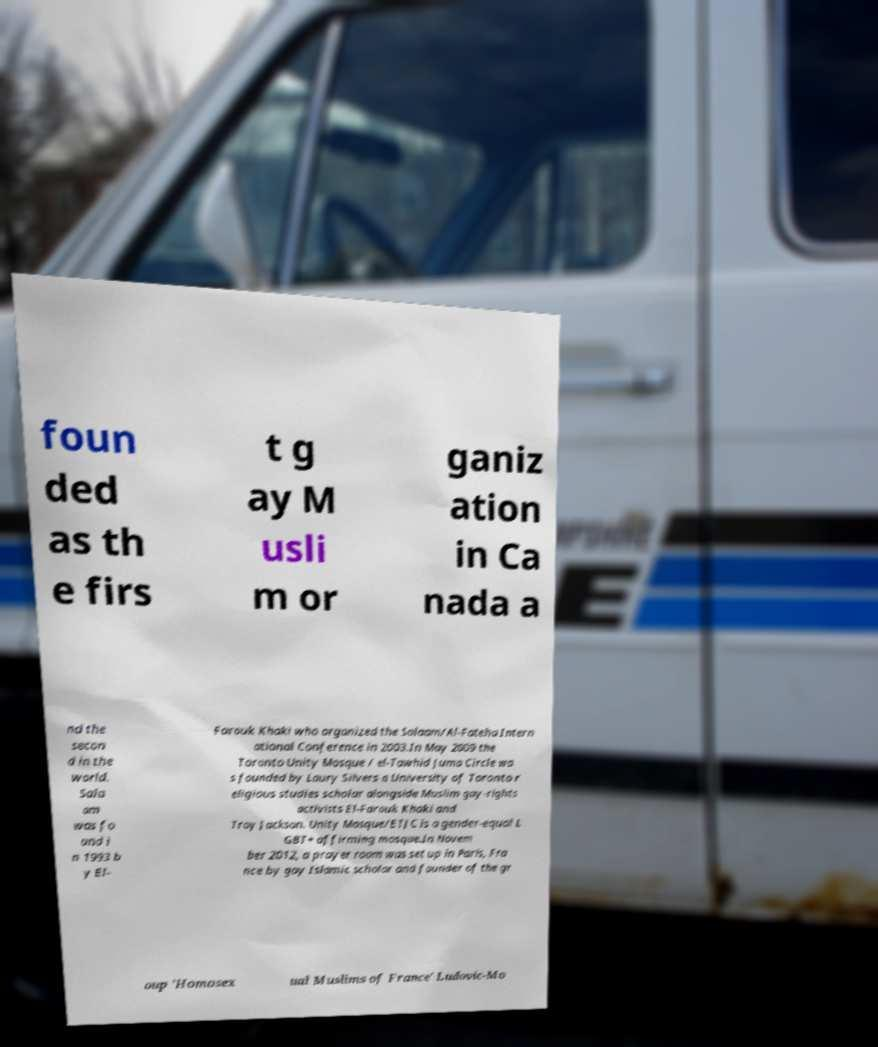Could you extract and type out the text from this image? foun ded as th e firs t g ay M usli m or ganiz ation in Ca nada a nd the secon d in the world. Sala am was fo und i n 1993 b y El- Farouk Khaki who organized the Salaam/Al-Fateha Intern ational Conference in 2003.In May 2009 the Toronto Unity Mosque / el-Tawhid Juma Circle wa s founded by Laury Silvers a University of Toronto r eligious studies scholar alongside Muslim gay-rights activists El-Farouk Khaki and Troy Jackson. Unity Mosque/ETJC is a gender-equal L GBT+ affirming mosque.In Novem ber 2012, a prayer room was set up in Paris, Fra nce by gay Islamic scholar and founder of the gr oup 'Homosex ual Muslims of France' Ludovic-Mo 